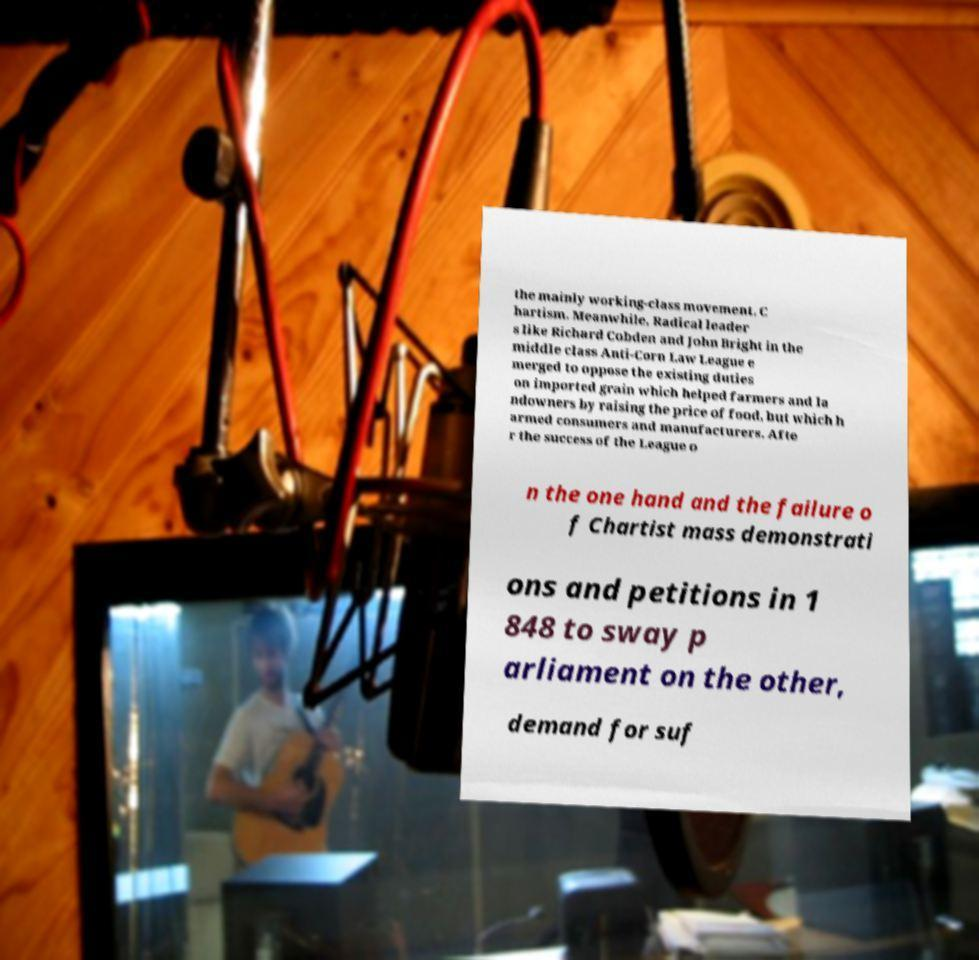For documentation purposes, I need the text within this image transcribed. Could you provide that? the mainly working-class movement, C hartism. Meanwhile, Radical leader s like Richard Cobden and John Bright in the middle class Anti-Corn Law League e merged to oppose the existing duties on imported grain which helped farmers and la ndowners by raising the price of food, but which h armed consumers and manufacturers. Afte r the success of the League o n the one hand and the failure o f Chartist mass demonstrati ons and petitions in 1 848 to sway p arliament on the other, demand for suf 